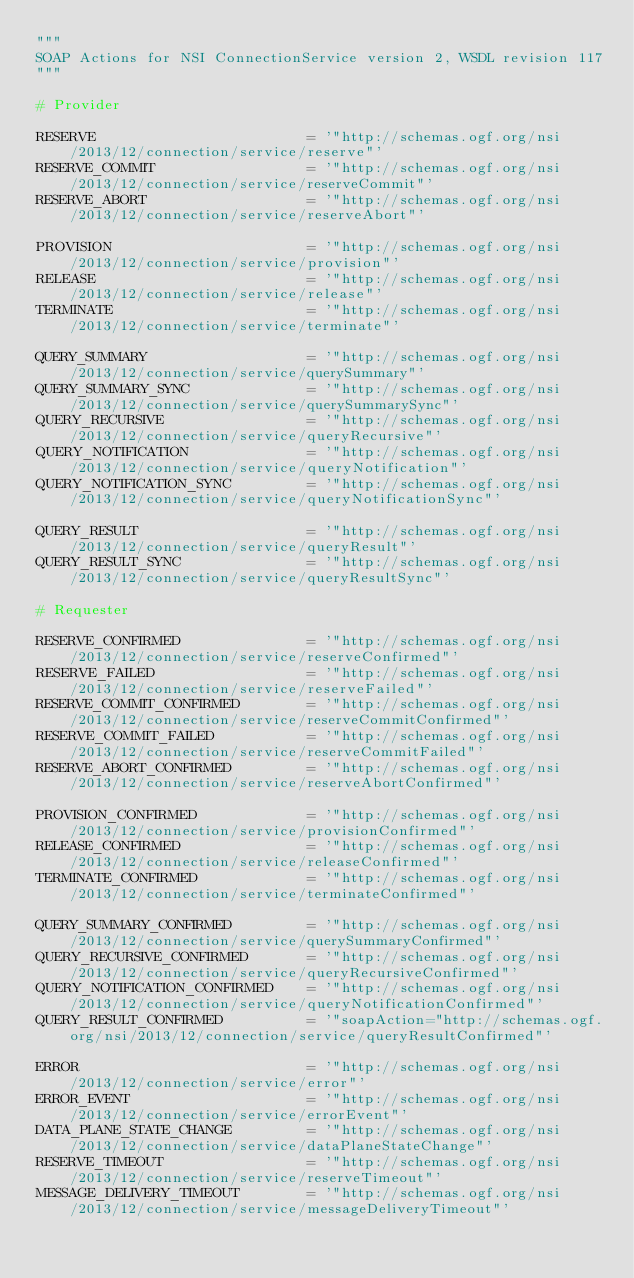<code> <loc_0><loc_0><loc_500><loc_500><_Python_>"""
SOAP Actions for NSI ConnectionService version 2, WSDL revision 117
"""

# Provider

RESERVE                         = '"http://schemas.ogf.org/nsi/2013/12/connection/service/reserve"'
RESERVE_COMMIT                  = '"http://schemas.ogf.org/nsi/2013/12/connection/service/reserveCommit"'
RESERVE_ABORT                   = '"http://schemas.ogf.org/nsi/2013/12/connection/service/reserveAbort"'

PROVISION                       = '"http://schemas.ogf.org/nsi/2013/12/connection/service/provision"'
RELEASE                         = '"http://schemas.ogf.org/nsi/2013/12/connection/service/release"'
TERMINATE                       = '"http://schemas.ogf.org/nsi/2013/12/connection/service/terminate"'

QUERY_SUMMARY                   = '"http://schemas.ogf.org/nsi/2013/12/connection/service/querySummary"'
QUERY_SUMMARY_SYNC              = '"http://schemas.ogf.org/nsi/2013/12/connection/service/querySummarySync"'
QUERY_RECURSIVE                 = '"http://schemas.ogf.org/nsi/2013/12/connection/service/queryRecursive"'
QUERY_NOTIFICATION              = '"http://schemas.ogf.org/nsi/2013/12/connection/service/queryNotification"'
QUERY_NOTIFICATION_SYNC         = '"http://schemas.ogf.org/nsi/2013/12/connection/service/queryNotificationSync"'

QUERY_RESULT                    = '"http://schemas.ogf.org/nsi/2013/12/connection/service/queryResult"'
QUERY_RESULT_SYNC               = '"http://schemas.ogf.org/nsi/2013/12/connection/service/queryResultSync"'

# Requester

RESERVE_CONFIRMED               = '"http://schemas.ogf.org/nsi/2013/12/connection/service/reserveConfirmed"'
RESERVE_FAILED                  = '"http://schemas.ogf.org/nsi/2013/12/connection/service/reserveFailed"'
RESERVE_COMMIT_CONFIRMED        = '"http://schemas.ogf.org/nsi/2013/12/connection/service/reserveCommitConfirmed"'
RESERVE_COMMIT_FAILED           = '"http://schemas.ogf.org/nsi/2013/12/connection/service/reserveCommitFailed"'
RESERVE_ABORT_CONFIRMED         = '"http://schemas.ogf.org/nsi/2013/12/connection/service/reserveAbortConfirmed"'

PROVISION_CONFIRMED             = '"http://schemas.ogf.org/nsi/2013/12/connection/service/provisionConfirmed"'
RELEASE_CONFIRMED               = '"http://schemas.ogf.org/nsi/2013/12/connection/service/releaseConfirmed"'
TERMINATE_CONFIRMED             = '"http://schemas.ogf.org/nsi/2013/12/connection/service/terminateConfirmed"'

QUERY_SUMMARY_CONFIRMED         = '"http://schemas.ogf.org/nsi/2013/12/connection/service/querySummaryConfirmed"'
QUERY_RECURSIVE_CONFIRMED       = '"http://schemas.ogf.org/nsi/2013/12/connection/service/queryRecursiveConfirmed"'
QUERY_NOTIFICATION_CONFIRMED    = '"http://schemas.ogf.org/nsi/2013/12/connection/service/queryNotificationConfirmed"'
QUERY_RESULT_CONFIRMED          = '"soapAction="http://schemas.ogf.org/nsi/2013/12/connection/service/queryResultConfirmed"'

ERROR                           = '"http://schemas.ogf.org/nsi/2013/12/connection/service/error"'
ERROR_EVENT                     = '"http://schemas.ogf.org/nsi/2013/12/connection/service/errorEvent"'
DATA_PLANE_STATE_CHANGE         = '"http://schemas.ogf.org/nsi/2013/12/connection/service/dataPlaneStateChange"'
RESERVE_TIMEOUT                 = '"http://schemas.ogf.org/nsi/2013/12/connection/service/reserveTimeout"'
MESSAGE_DELIVERY_TIMEOUT        = '"http://schemas.ogf.org/nsi/2013/12/connection/service/messageDeliveryTimeout"'

</code> 